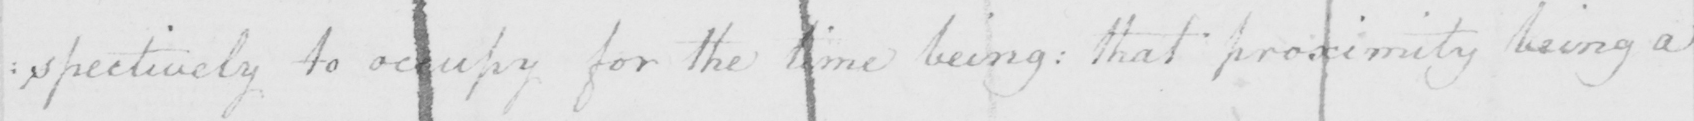What is written in this line of handwriting? : pectively to occupy for the time being :  that proximity being a 